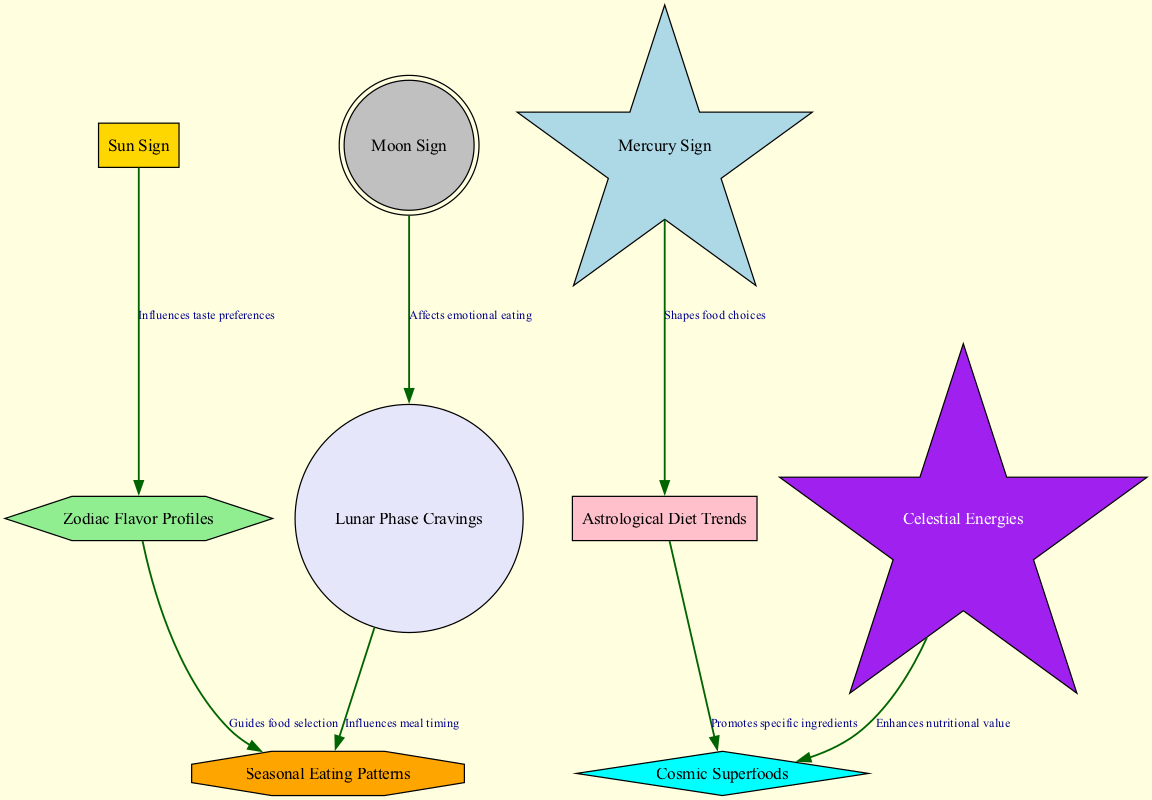What is the total number of nodes in the diagram? The diagram contains 9 nodes, which are listed within the 'nodes' section of the data.
Answer: 9 Which node influences taste preferences? The edge labeled "Influences taste preferences" connects "Sun Sign" to "Zodiac Flavor Profiles," indicating that the Sun Sign has this influence.
Answer: Sun Sign What relationship exists between Lunar Phase Cravings and Seasonal Eating Patterns? The edge labeled "Influences meal timing" shows that Lunar Phase Cravings affect Seasonal Eating Patterns, indicating a directional influence.
Answer: Influences meal timing Which sign shapes food choices? The relationship shows that the Mercury Sign connects to Astrological Diet Trends with the label "Shapes food choices," meaning this sign has the influence.
Answer: Mercury Sign What enhances the nutritional value of food? The diagram indicates that "Celestial Energies" connects to "Cosmic Superfoods," showing that these energies enhance the nutritional value of superfoods in astrology.
Answer: Celestial Energies How many edges are present in the diagram? The 'edges' section reveals there are 7 relationships (or edges) in total connecting the nodes.
Answer: 7 What guides food selection according to the diagram? The flow shows the edge from "Zodiac Flavor Profiles" to "Seasonal Eating Patterns," labeled as "Guides food selection," indicating this influence.
Answer: Zodiac Flavor Profiles Which two nodes are connected by the edge labeled "Promotes specific ingredients"? The edge labeled "Promotes specific ingredients" links "Astrological Diet Trends" to "Cosmic Superfoods," indicating the relationship between these two nodes.
Answer: Astrological Diet Trends and Cosmic Superfoods What is the function of the Moon Sign in the context of eating? The edge from "Moon Sign" to "Lunar Phase Cravings," labeled "Affects emotional eating," indicates that the Moon Sign influences emotional eating.
Answer: Affects emotional eating 